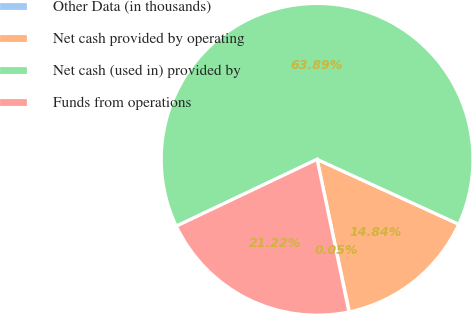Convert chart. <chart><loc_0><loc_0><loc_500><loc_500><pie_chart><fcel>Other Data (in thousands)<fcel>Net cash provided by operating<fcel>Net cash (used in) provided by<fcel>Funds from operations<nl><fcel>0.05%<fcel>14.84%<fcel>63.89%<fcel>21.22%<nl></chart> 